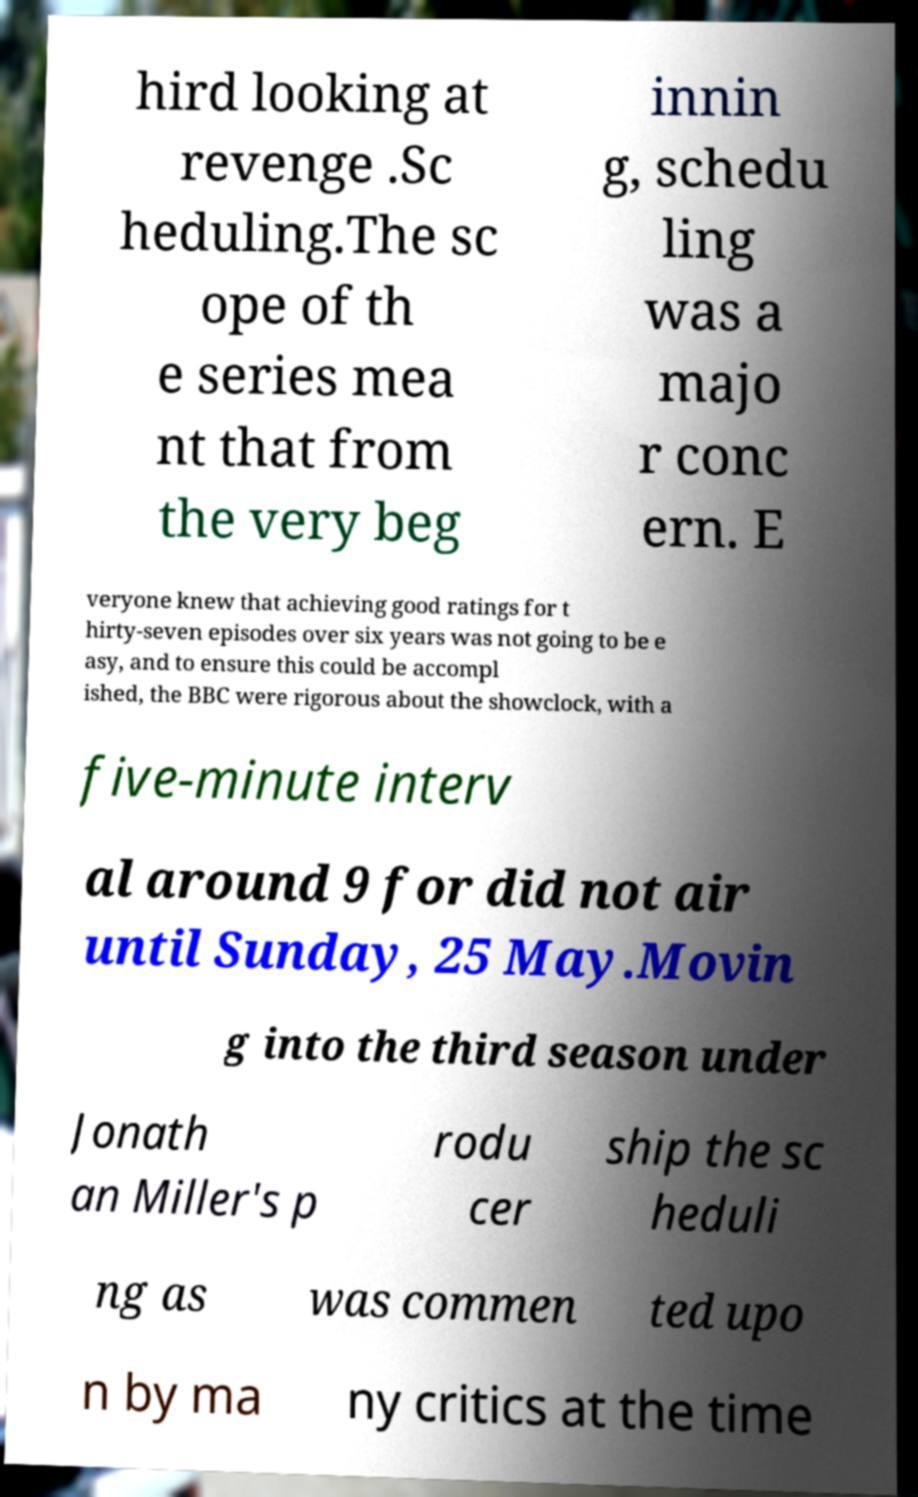There's text embedded in this image that I need extracted. Can you transcribe it verbatim? hird looking at revenge .Sc heduling.The sc ope of th e series mea nt that from the very beg innin g, schedu ling was a majo r conc ern. E veryone knew that achieving good ratings for t hirty-seven episodes over six years was not going to be e asy, and to ensure this could be accompl ished, the BBC were rigorous about the showclock, with a five-minute interv al around 9 for did not air until Sunday, 25 May.Movin g into the third season under Jonath an Miller's p rodu cer ship the sc heduli ng as was commen ted upo n by ma ny critics at the time 